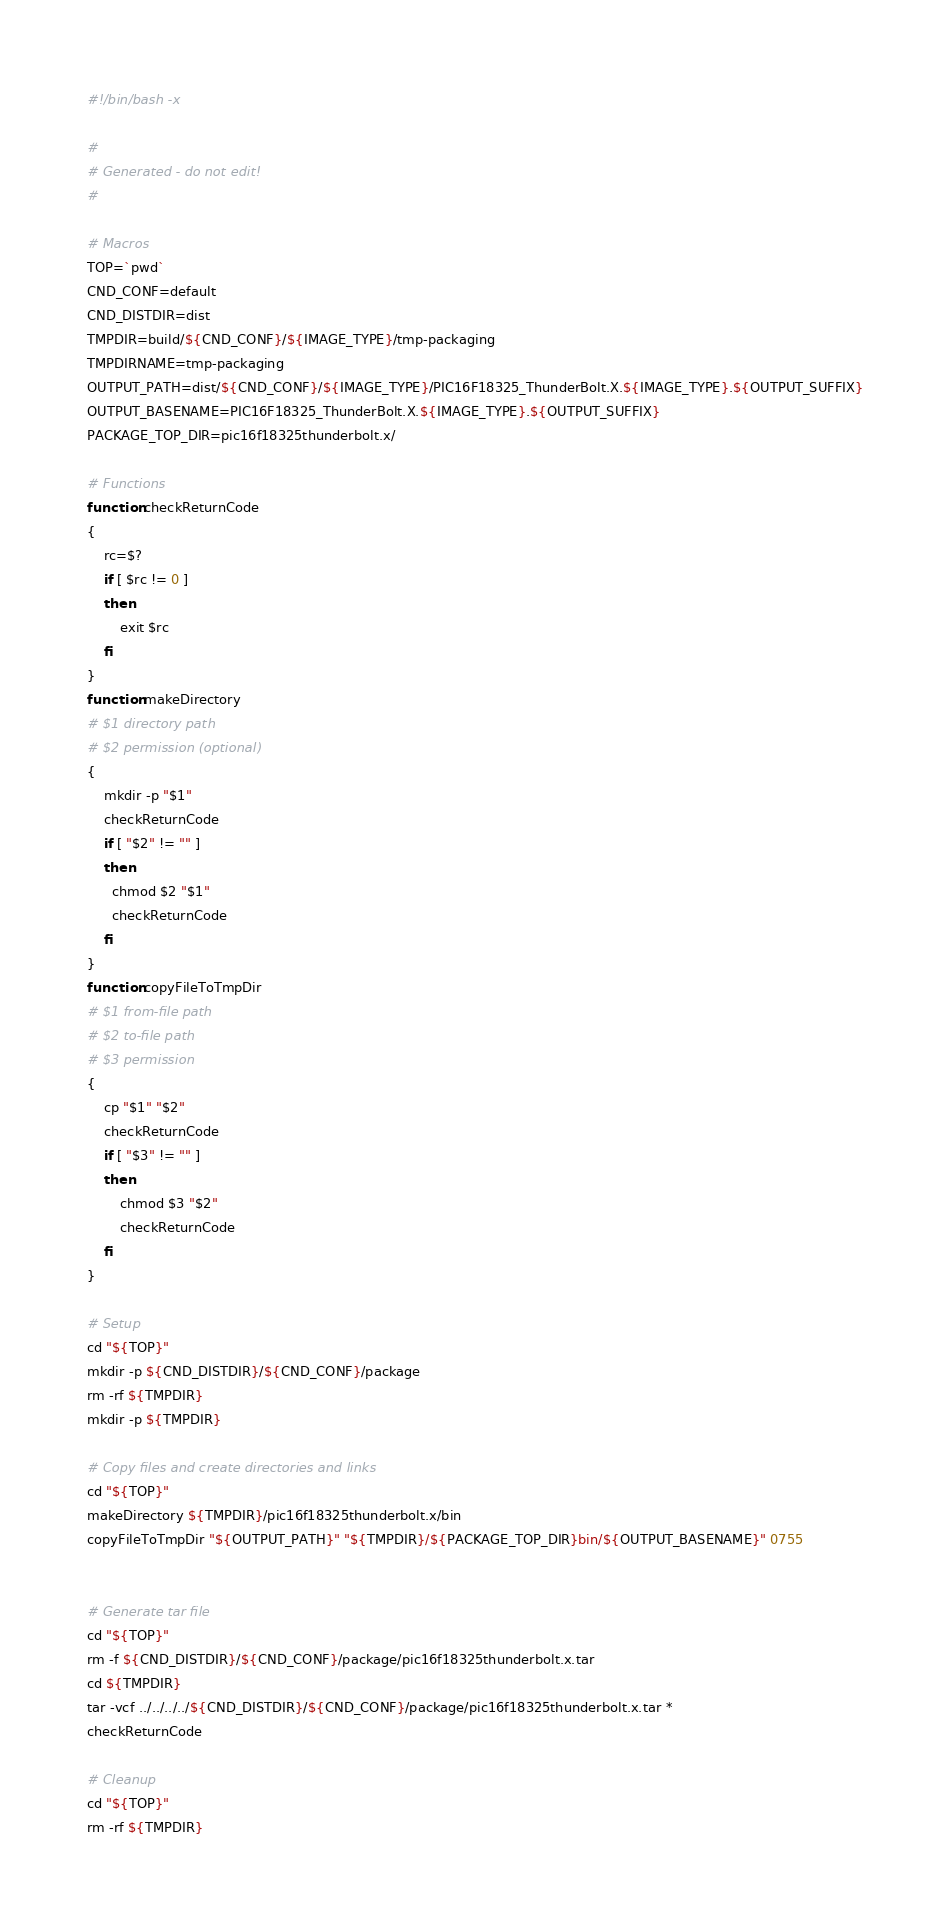<code> <loc_0><loc_0><loc_500><loc_500><_Bash_>#!/bin/bash -x

#
# Generated - do not edit!
#

# Macros
TOP=`pwd`
CND_CONF=default
CND_DISTDIR=dist
TMPDIR=build/${CND_CONF}/${IMAGE_TYPE}/tmp-packaging
TMPDIRNAME=tmp-packaging
OUTPUT_PATH=dist/${CND_CONF}/${IMAGE_TYPE}/PIC16F18325_ThunderBolt.X.${IMAGE_TYPE}.${OUTPUT_SUFFIX}
OUTPUT_BASENAME=PIC16F18325_ThunderBolt.X.${IMAGE_TYPE}.${OUTPUT_SUFFIX}
PACKAGE_TOP_DIR=pic16f18325thunderbolt.x/

# Functions
function checkReturnCode
{
    rc=$?
    if [ $rc != 0 ]
    then
        exit $rc
    fi
}
function makeDirectory
# $1 directory path
# $2 permission (optional)
{
    mkdir -p "$1"
    checkReturnCode
    if [ "$2" != "" ]
    then
      chmod $2 "$1"
      checkReturnCode
    fi
}
function copyFileToTmpDir
# $1 from-file path
# $2 to-file path
# $3 permission
{
    cp "$1" "$2"
    checkReturnCode
    if [ "$3" != "" ]
    then
        chmod $3 "$2"
        checkReturnCode
    fi
}

# Setup
cd "${TOP}"
mkdir -p ${CND_DISTDIR}/${CND_CONF}/package
rm -rf ${TMPDIR}
mkdir -p ${TMPDIR}

# Copy files and create directories and links
cd "${TOP}"
makeDirectory ${TMPDIR}/pic16f18325thunderbolt.x/bin
copyFileToTmpDir "${OUTPUT_PATH}" "${TMPDIR}/${PACKAGE_TOP_DIR}bin/${OUTPUT_BASENAME}" 0755


# Generate tar file
cd "${TOP}"
rm -f ${CND_DISTDIR}/${CND_CONF}/package/pic16f18325thunderbolt.x.tar
cd ${TMPDIR}
tar -vcf ../../../../${CND_DISTDIR}/${CND_CONF}/package/pic16f18325thunderbolt.x.tar *
checkReturnCode

# Cleanup
cd "${TOP}"
rm -rf ${TMPDIR}
</code> 